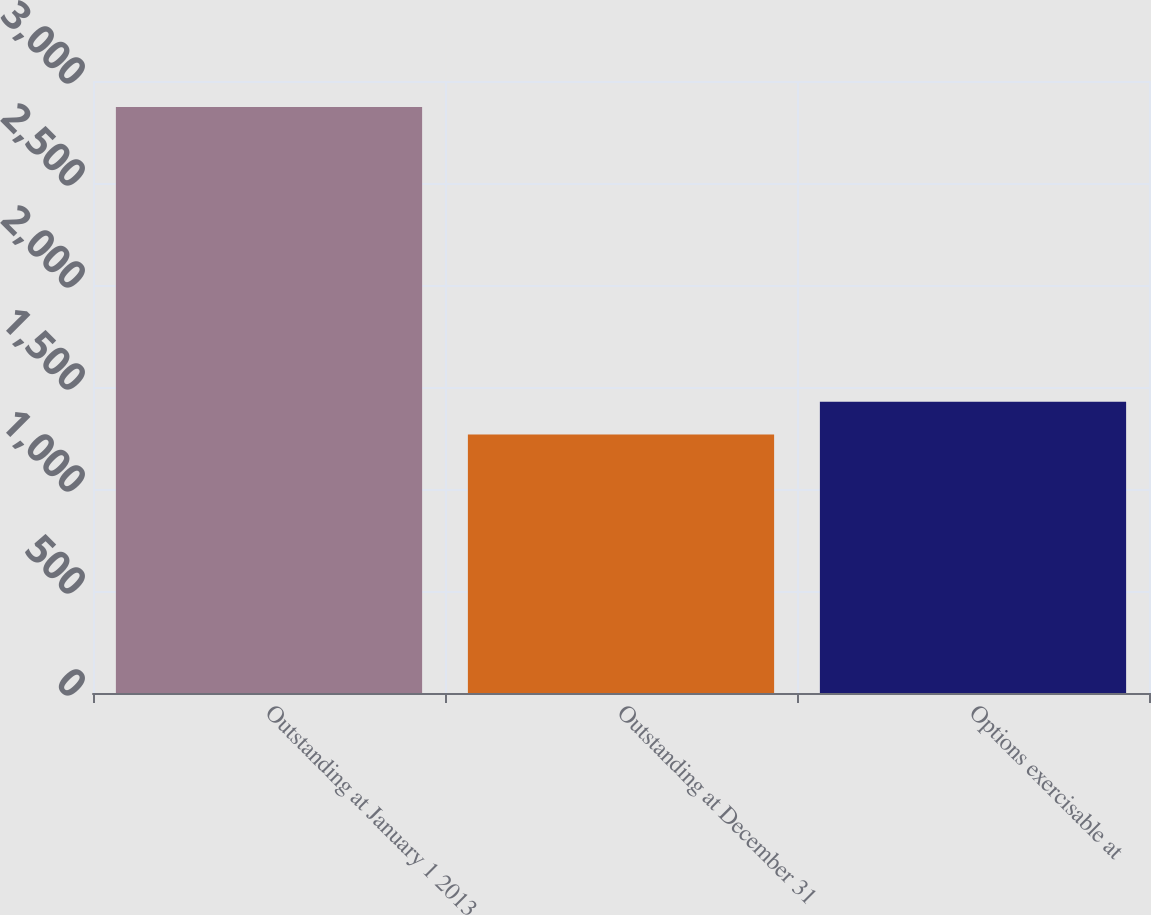Convert chart. <chart><loc_0><loc_0><loc_500><loc_500><bar_chart><fcel>Outstanding at January 1 2013<fcel>Outstanding at December 31<fcel>Options exercisable at<nl><fcel>2872<fcel>1267<fcel>1427.5<nl></chart> 